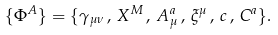Convert formula to latex. <formula><loc_0><loc_0><loc_500><loc_500>\{ \Phi ^ { A } \} = \{ \gamma _ { \mu \nu } \, , \, X ^ { M } \, , \, A _ { \mu } ^ { a } \, , \, \xi ^ { \mu } \, , \, c \, , \, C ^ { a } \} .</formula> 